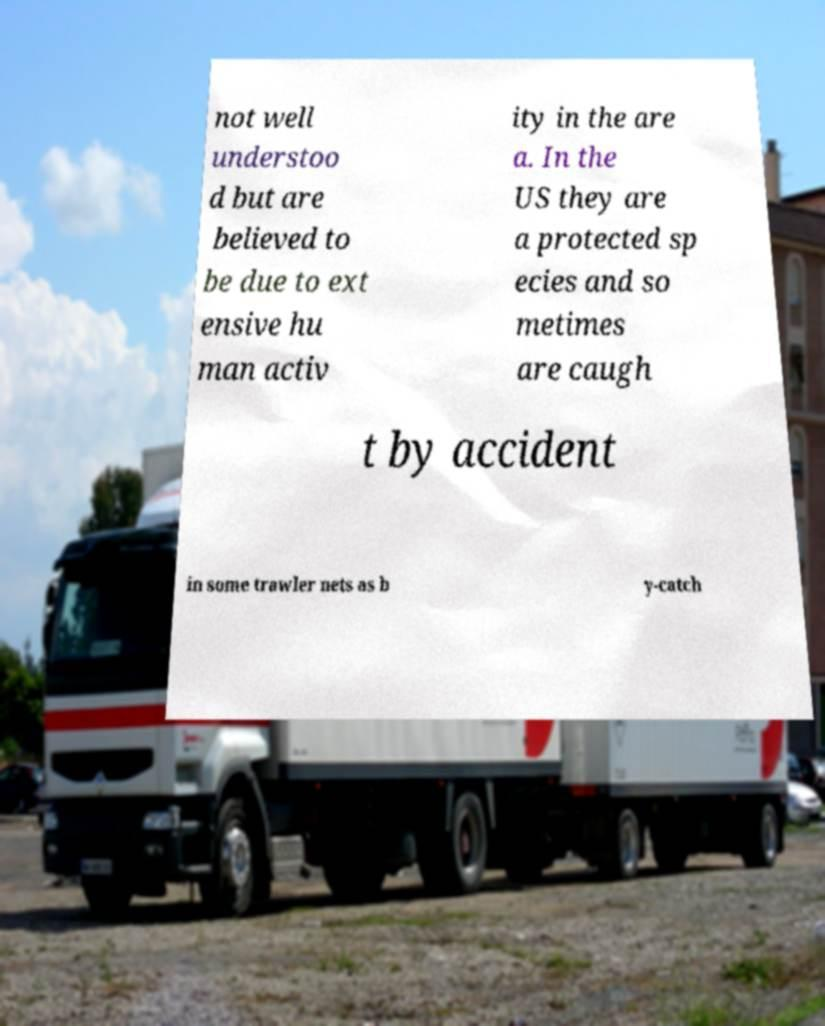There's text embedded in this image that I need extracted. Can you transcribe it verbatim? not well understoo d but are believed to be due to ext ensive hu man activ ity in the are a. In the US they are a protected sp ecies and so metimes are caugh t by accident in some trawler nets as b y-catch 